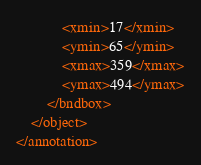Convert code to text. <code><loc_0><loc_0><loc_500><loc_500><_XML_>			<xmin>17</xmin>
			<ymin>65</ymin>
			<xmax>359</xmax>
			<ymax>494</ymax>
		</bndbox>
	</object>
</annotation>
</code> 